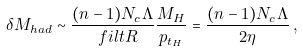<formula> <loc_0><loc_0><loc_500><loc_500>\delta M _ { h a d } \sim \frac { ( n - 1 ) N _ { c } \Lambda } { \ f i l t { R } } \frac { M _ { H } } { p _ { t _ { H } } } = \frac { ( n - 1 ) N _ { c } \Lambda } { 2 \eta } \, ,</formula> 